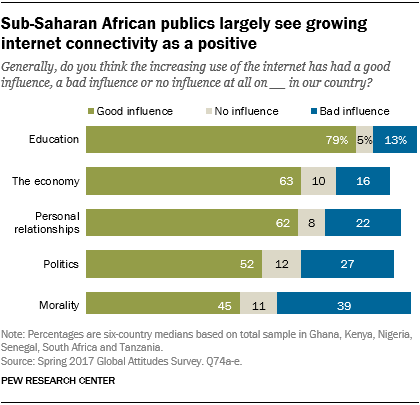Give some essential details in this illustration. According to a recent survey of the sub-Saharan African public, 79% believe that the increasing use of the internet has had a positive impact on education. A recent survey of the public in sub-Saharan Africa found that a significant majority, at 2.185416667..., believe that the increasing use of the internet has had a positive influence on politics. 